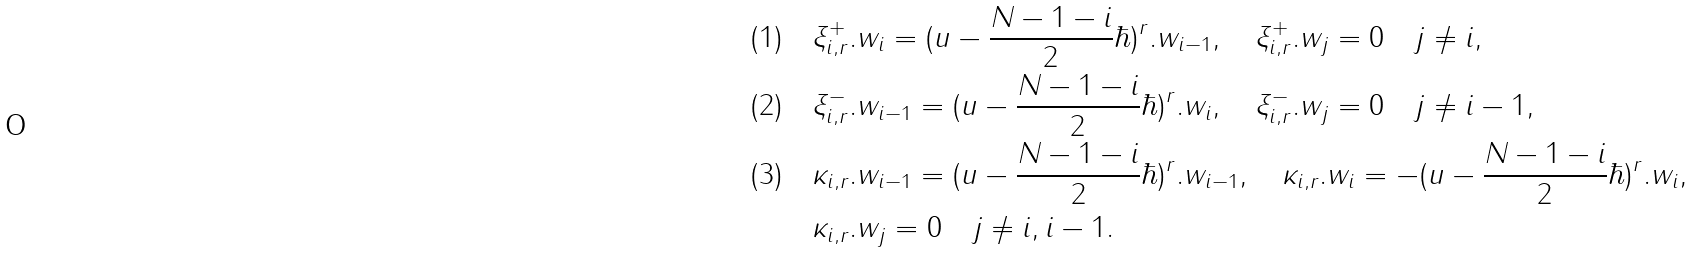Convert formula to latex. <formula><loc_0><loc_0><loc_500><loc_500>( 1 ) \quad & \xi ^ { + } _ { i , r } . w _ { i } = ( u - \frac { N - 1 - i } { 2 } \hbar { ) } ^ { r } . w _ { i - 1 } , \quad \xi ^ { + } _ { i , r } . w _ { j } = 0 \quad j \neq i , \\ ( 2 ) \quad & \xi ^ { - } _ { i , r } . w _ { i - 1 } = ( u - \frac { N - 1 - i } { 2 } \hbar { ) } ^ { r } . w _ { i } , \quad \xi ^ { - } _ { i , r } . w _ { j } = 0 \quad j \neq i - 1 , \\ ( 3 ) \quad & \kappa _ { i , r } . w _ { i - 1 } = ( u - \frac { N - 1 - i } { 2 } \hbar { ) } ^ { r } . w _ { i - 1 } , \quad \kappa _ { i , r } . w _ { i } = - ( u - \frac { N - 1 - i } { 2 } \hbar { ) } ^ { r } . w _ { i } , \\ & \kappa _ { i , r } . w _ { j } = 0 \quad j \neq i , i - 1 .</formula> 